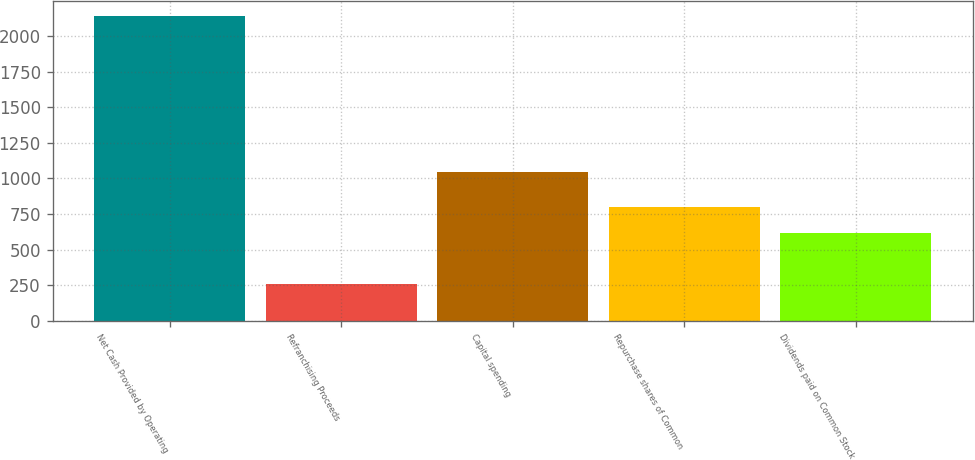<chart> <loc_0><loc_0><loc_500><loc_500><bar_chart><fcel>Net Cash Provided by Operating<fcel>Refranchising Proceeds<fcel>Capital spending<fcel>Repurchase shares of Common<fcel>Dividends paid on Common Stock<nl><fcel>2139<fcel>260<fcel>1049<fcel>802.9<fcel>615<nl></chart> 